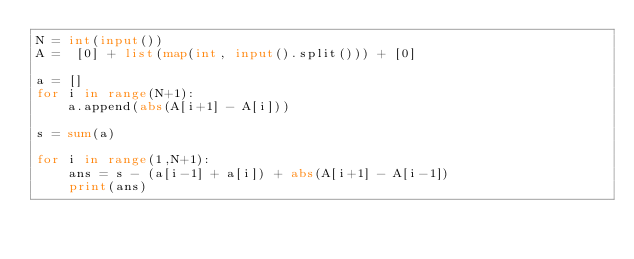<code> <loc_0><loc_0><loc_500><loc_500><_Python_>N = int(input())
A =  [0] + list(map(int, input().split())) + [0]

a = []
for i in range(N+1):
    a.append(abs(A[i+1] - A[i]))
    
s = sum(a)

for i in range(1,N+1):
    ans = s - (a[i-1] + a[i]) + abs(A[i+1] - A[i-1])
    print(ans)</code> 